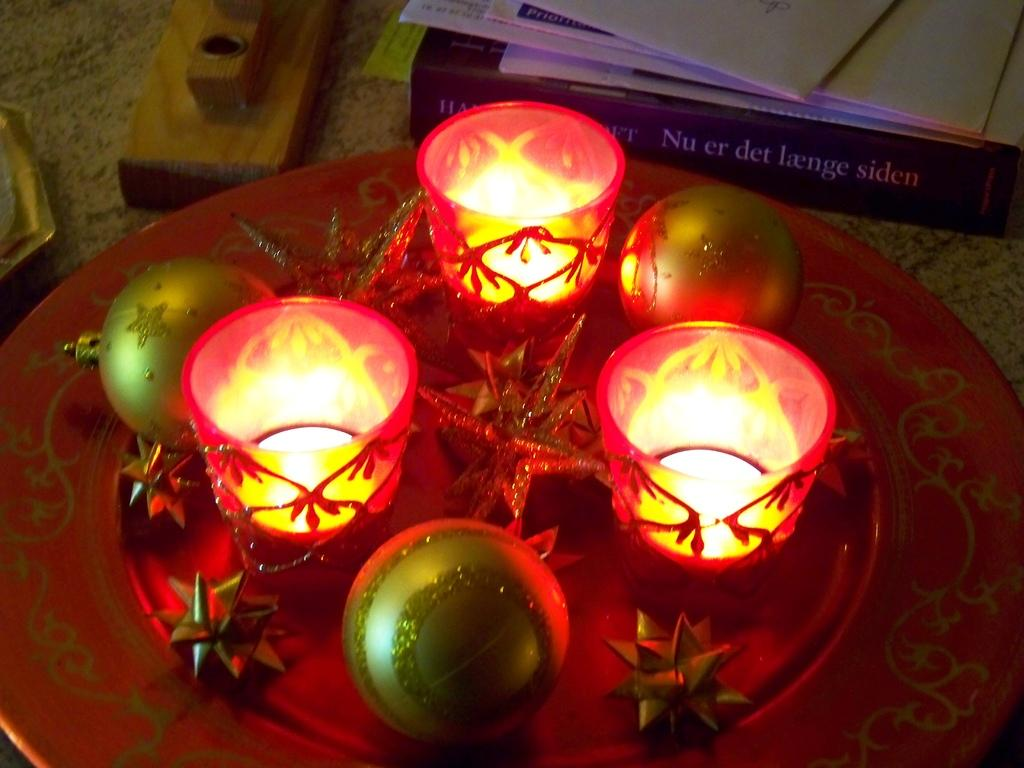What type of objects can be seen in the image? There are glasses, decorative items on a plate, a book, papers, and a wooden object in the image. Where are these objects located? All of these items are placed on a platform. What might be the purpose of the wooden object in the image? The wooden object could be a decorative item or a functional object, but its specific purpose cannot be determined from the image alone. What type of material is the book made of? The book is made of paper, as indicated by the fact that there are papers in the image as well. What type of skin condition can be seen on the book in the image? There is no skin condition present on the book in the image, as books are made of paper and do not have skin. 